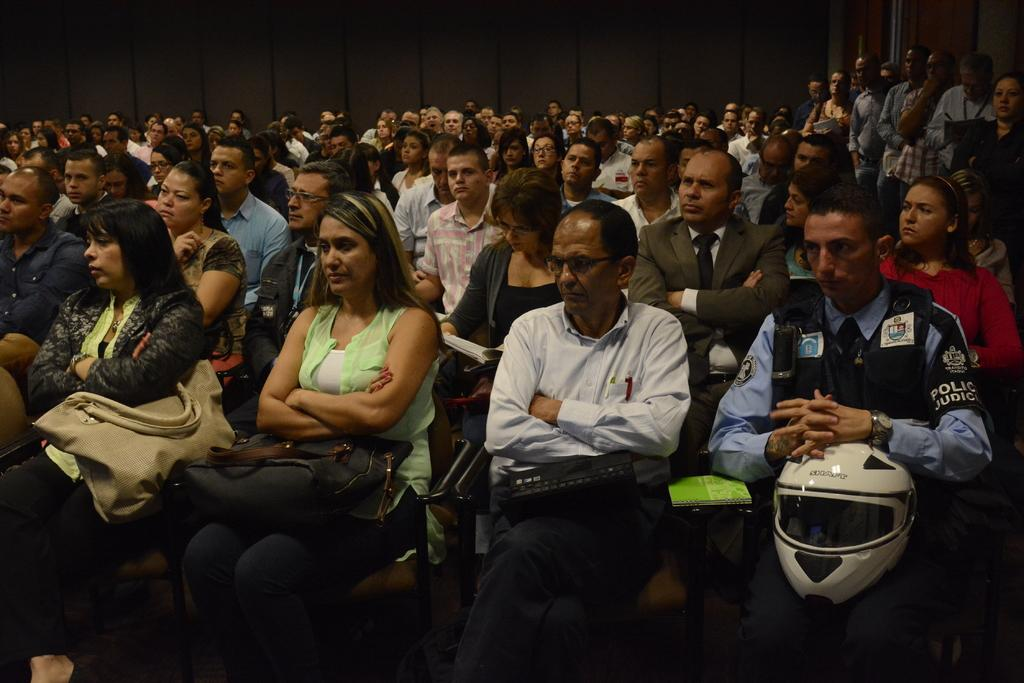How many people are in the image? There are people in the image, but the exact number is not specified. What are the people doing in the image? Most of the people are sitting on chairs, while some people are standing. What can be seen on the wall in the image? The facts do not mention anything specific about the wall. What items can be seen in the image related to carrying or storing things? There are bags and books in the image. What protective gear is visible in the image? There are helmets in the image. What other objects can be seen in the image? There are other objects in the image, but their specifics are not mentioned. How many scissors are being used by the people in the image? There is no mention of scissors in the image, so it is impossible to determine how many are being used. What type of stick is being held by the people in the image? There is no mention of a stick in the image, so it is impossible to determine what type of stick might be held by the people. 